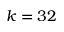Convert formula to latex. <formula><loc_0><loc_0><loc_500><loc_500>k = 3 2</formula> 